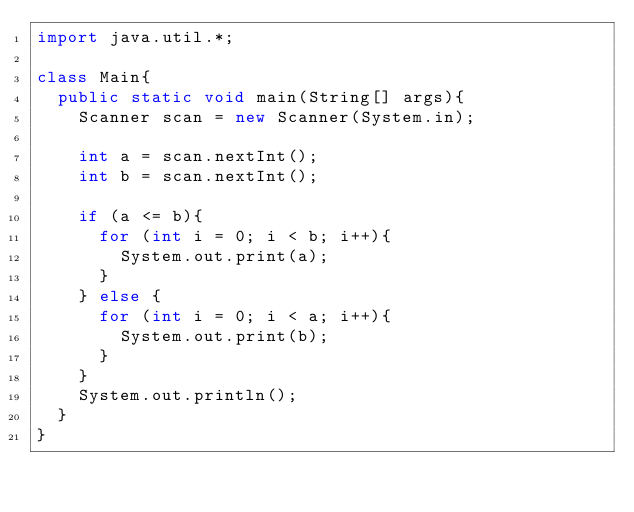Convert code to text. <code><loc_0><loc_0><loc_500><loc_500><_Java_>import java.util.*;

class Main{
  public static void main(String[] args){
    Scanner scan = new Scanner(System.in);
    
    int a = scan.nextInt();
    int b = scan.nextInt();
    
    if (a <= b){
      for (int i = 0; i < b; i++){
        System.out.print(a);
      }
    } else {
      for (int i = 0; i < a; i++){
        System.out.print(b);
      }
    }
    System.out.println();
  }
}</code> 